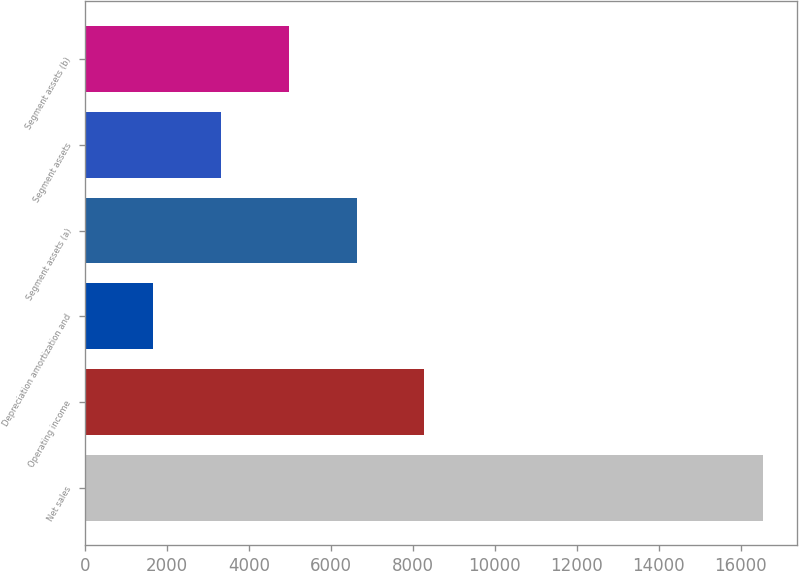Convert chart. <chart><loc_0><loc_0><loc_500><loc_500><bar_chart><fcel>Net sales<fcel>Operating income<fcel>Depreciation amortization and<fcel>Segment assets (a)<fcel>Segment assets<fcel>Segment assets (b)<nl><fcel>16552<fcel>8281<fcel>1664.2<fcel>6626.8<fcel>3318.4<fcel>4972.6<nl></chart> 